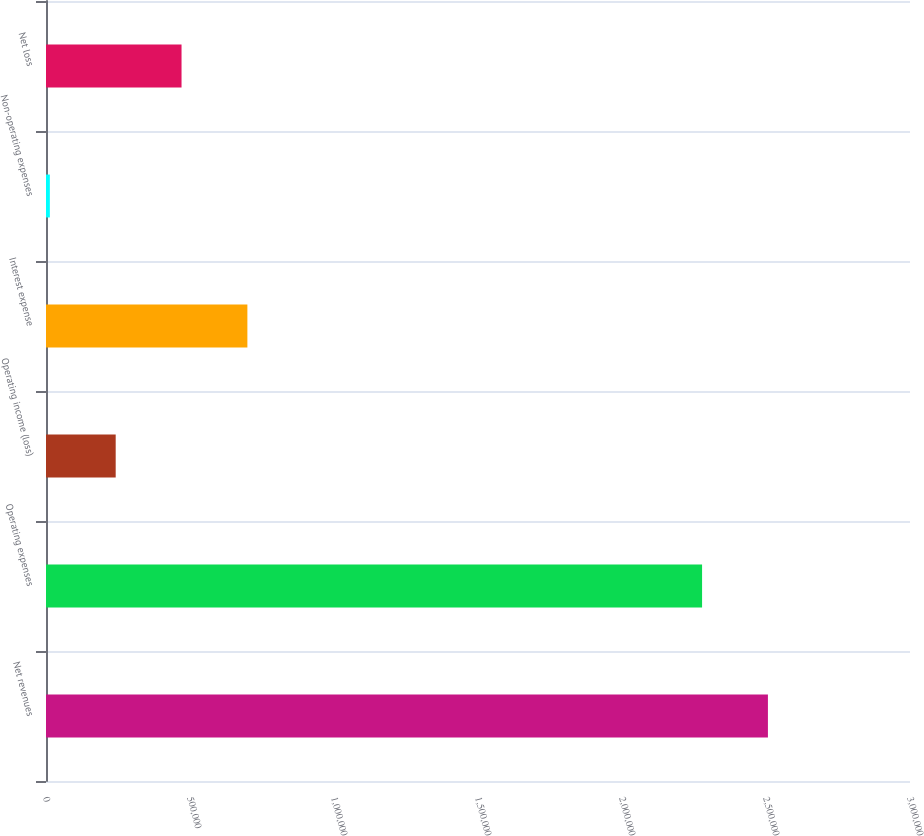<chart> <loc_0><loc_0><loc_500><loc_500><bar_chart><fcel>Net revenues<fcel>Operating expenses<fcel>Operating income (loss)<fcel>Interest expense<fcel>Non-operating expenses<fcel>Net loss<nl><fcel>2.50668e+06<fcel>2.27804e+06<fcel>241973<fcel>699245<fcel>13337<fcel>470609<nl></chart> 